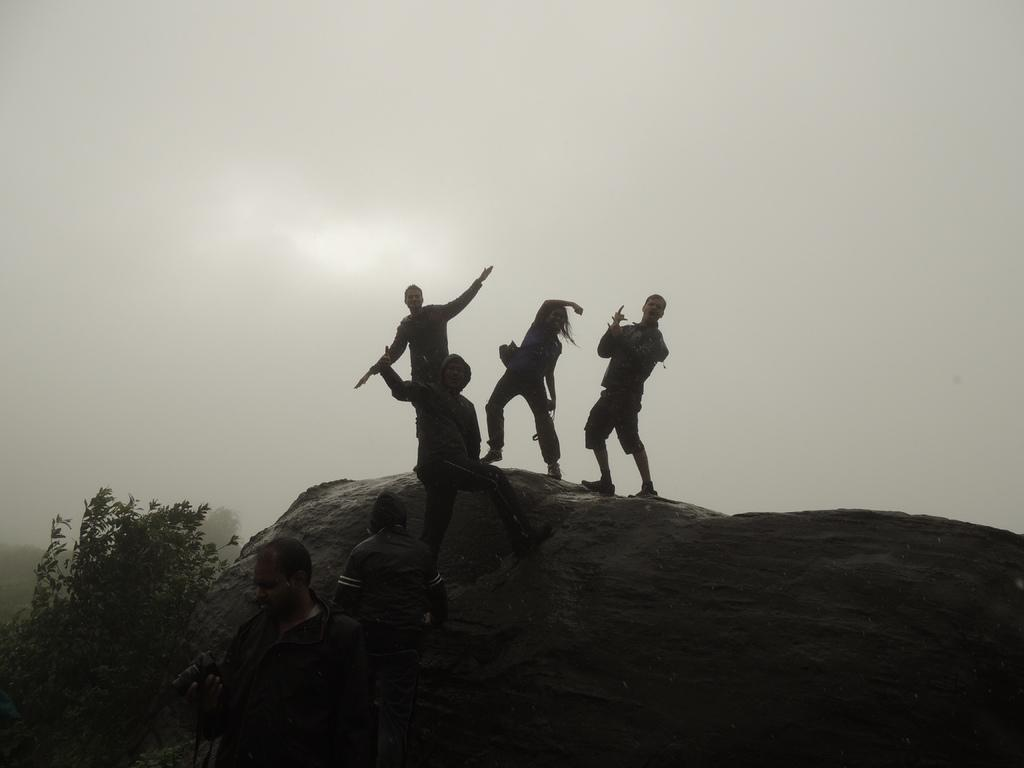What are the persons in the image standing on? The persons in the image are standing on a rock. What can be seen above the rock in the image? The sky is visible above the rock in the image. What type of paper is being used by the birds in the image? There are no birds present in the image, so there is no paper being used by them. 